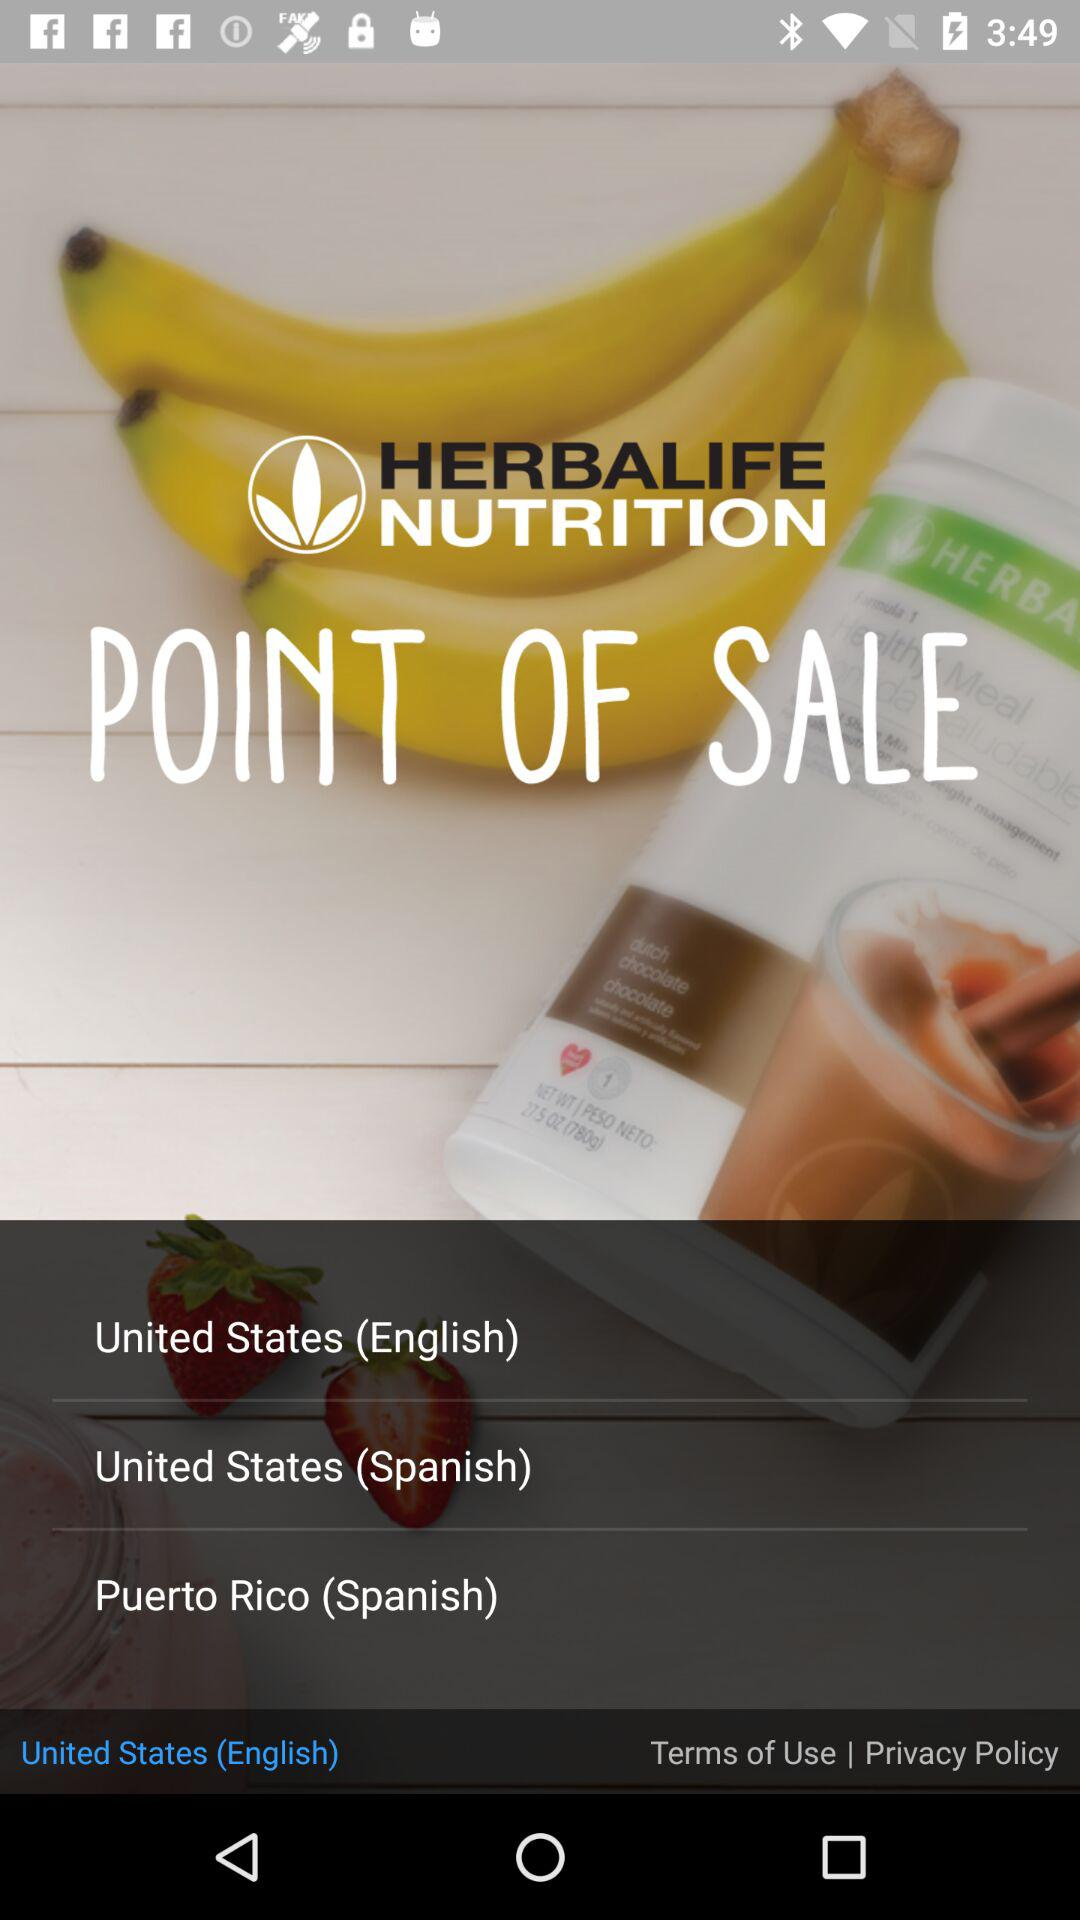Which option is selected? The selected option is "United States (English)". 